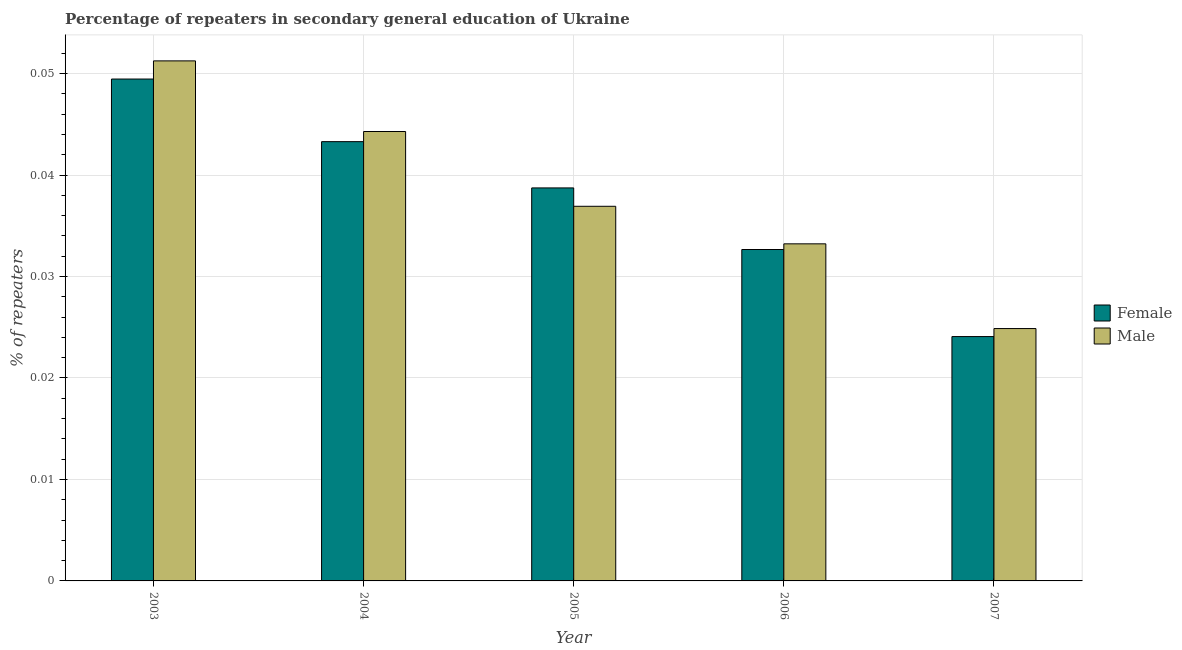How many bars are there on the 5th tick from the left?
Offer a terse response. 2. What is the percentage of female repeaters in 2003?
Keep it short and to the point. 0.05. Across all years, what is the maximum percentage of female repeaters?
Offer a very short reply. 0.05. Across all years, what is the minimum percentage of female repeaters?
Your answer should be compact. 0.02. In which year was the percentage of female repeaters minimum?
Make the answer very short. 2007. What is the total percentage of female repeaters in the graph?
Give a very brief answer. 0.19. What is the difference between the percentage of female repeaters in 2004 and that in 2006?
Keep it short and to the point. 0.01. What is the difference between the percentage of male repeaters in 2005 and the percentage of female repeaters in 2006?
Offer a terse response. 0. What is the average percentage of male repeaters per year?
Provide a succinct answer. 0.04. In the year 2003, what is the difference between the percentage of female repeaters and percentage of male repeaters?
Provide a succinct answer. 0. In how many years, is the percentage of male repeaters greater than 0.04 %?
Make the answer very short. 2. What is the ratio of the percentage of female repeaters in 2005 to that in 2007?
Keep it short and to the point. 1.61. What is the difference between the highest and the second highest percentage of female repeaters?
Provide a short and direct response. 0.01. What is the difference between the highest and the lowest percentage of male repeaters?
Provide a short and direct response. 0.03. Is the sum of the percentage of female repeaters in 2004 and 2007 greater than the maximum percentage of male repeaters across all years?
Your response must be concise. Yes. What does the 2nd bar from the left in 2004 represents?
Ensure brevity in your answer.  Male. How many bars are there?
Your response must be concise. 10. How many years are there in the graph?
Offer a very short reply. 5. Are the values on the major ticks of Y-axis written in scientific E-notation?
Ensure brevity in your answer.  No. Does the graph contain grids?
Provide a succinct answer. Yes. How are the legend labels stacked?
Offer a terse response. Vertical. What is the title of the graph?
Offer a very short reply. Percentage of repeaters in secondary general education of Ukraine. What is the label or title of the Y-axis?
Make the answer very short. % of repeaters. What is the % of repeaters in Female in 2003?
Your answer should be compact. 0.05. What is the % of repeaters of Male in 2003?
Provide a succinct answer. 0.05. What is the % of repeaters in Female in 2004?
Offer a terse response. 0.04. What is the % of repeaters in Male in 2004?
Keep it short and to the point. 0.04. What is the % of repeaters of Female in 2005?
Make the answer very short. 0.04. What is the % of repeaters of Male in 2005?
Your answer should be very brief. 0.04. What is the % of repeaters of Female in 2006?
Provide a short and direct response. 0.03. What is the % of repeaters in Male in 2006?
Your response must be concise. 0.03. What is the % of repeaters of Female in 2007?
Make the answer very short. 0.02. What is the % of repeaters in Male in 2007?
Make the answer very short. 0.02. Across all years, what is the maximum % of repeaters of Female?
Your answer should be compact. 0.05. Across all years, what is the maximum % of repeaters in Male?
Provide a succinct answer. 0.05. Across all years, what is the minimum % of repeaters in Female?
Make the answer very short. 0.02. Across all years, what is the minimum % of repeaters of Male?
Give a very brief answer. 0.02. What is the total % of repeaters of Female in the graph?
Offer a terse response. 0.19. What is the total % of repeaters of Male in the graph?
Your answer should be very brief. 0.19. What is the difference between the % of repeaters in Female in 2003 and that in 2004?
Ensure brevity in your answer.  0.01. What is the difference between the % of repeaters in Male in 2003 and that in 2004?
Your response must be concise. 0.01. What is the difference between the % of repeaters in Female in 2003 and that in 2005?
Give a very brief answer. 0.01. What is the difference between the % of repeaters of Male in 2003 and that in 2005?
Give a very brief answer. 0.01. What is the difference between the % of repeaters in Female in 2003 and that in 2006?
Give a very brief answer. 0.02. What is the difference between the % of repeaters in Male in 2003 and that in 2006?
Give a very brief answer. 0.02. What is the difference between the % of repeaters of Female in 2003 and that in 2007?
Your answer should be compact. 0.03. What is the difference between the % of repeaters in Male in 2003 and that in 2007?
Make the answer very short. 0.03. What is the difference between the % of repeaters in Female in 2004 and that in 2005?
Offer a terse response. 0. What is the difference between the % of repeaters in Male in 2004 and that in 2005?
Keep it short and to the point. 0.01. What is the difference between the % of repeaters in Female in 2004 and that in 2006?
Keep it short and to the point. 0.01. What is the difference between the % of repeaters of Male in 2004 and that in 2006?
Make the answer very short. 0.01. What is the difference between the % of repeaters in Female in 2004 and that in 2007?
Ensure brevity in your answer.  0.02. What is the difference between the % of repeaters of Male in 2004 and that in 2007?
Provide a succinct answer. 0.02. What is the difference between the % of repeaters of Female in 2005 and that in 2006?
Offer a terse response. 0.01. What is the difference between the % of repeaters of Male in 2005 and that in 2006?
Ensure brevity in your answer.  0. What is the difference between the % of repeaters of Female in 2005 and that in 2007?
Make the answer very short. 0.01. What is the difference between the % of repeaters in Male in 2005 and that in 2007?
Make the answer very short. 0.01. What is the difference between the % of repeaters in Female in 2006 and that in 2007?
Your response must be concise. 0.01. What is the difference between the % of repeaters in Male in 2006 and that in 2007?
Offer a very short reply. 0.01. What is the difference between the % of repeaters in Female in 2003 and the % of repeaters in Male in 2004?
Offer a terse response. 0.01. What is the difference between the % of repeaters in Female in 2003 and the % of repeaters in Male in 2005?
Your response must be concise. 0.01. What is the difference between the % of repeaters in Female in 2003 and the % of repeaters in Male in 2006?
Provide a succinct answer. 0.02. What is the difference between the % of repeaters of Female in 2003 and the % of repeaters of Male in 2007?
Offer a very short reply. 0.02. What is the difference between the % of repeaters in Female in 2004 and the % of repeaters in Male in 2005?
Ensure brevity in your answer.  0.01. What is the difference between the % of repeaters of Female in 2004 and the % of repeaters of Male in 2006?
Your response must be concise. 0.01. What is the difference between the % of repeaters of Female in 2004 and the % of repeaters of Male in 2007?
Provide a succinct answer. 0.02. What is the difference between the % of repeaters in Female in 2005 and the % of repeaters in Male in 2006?
Your response must be concise. 0.01. What is the difference between the % of repeaters of Female in 2005 and the % of repeaters of Male in 2007?
Make the answer very short. 0.01. What is the difference between the % of repeaters of Female in 2006 and the % of repeaters of Male in 2007?
Keep it short and to the point. 0.01. What is the average % of repeaters of Female per year?
Give a very brief answer. 0.04. What is the average % of repeaters of Male per year?
Keep it short and to the point. 0.04. In the year 2003, what is the difference between the % of repeaters of Female and % of repeaters of Male?
Your answer should be very brief. -0. In the year 2004, what is the difference between the % of repeaters of Female and % of repeaters of Male?
Give a very brief answer. -0. In the year 2005, what is the difference between the % of repeaters of Female and % of repeaters of Male?
Offer a terse response. 0. In the year 2006, what is the difference between the % of repeaters of Female and % of repeaters of Male?
Provide a short and direct response. -0. In the year 2007, what is the difference between the % of repeaters of Female and % of repeaters of Male?
Your answer should be compact. -0. What is the ratio of the % of repeaters of Female in 2003 to that in 2004?
Offer a very short reply. 1.14. What is the ratio of the % of repeaters of Male in 2003 to that in 2004?
Your answer should be very brief. 1.16. What is the ratio of the % of repeaters of Female in 2003 to that in 2005?
Your answer should be compact. 1.28. What is the ratio of the % of repeaters in Male in 2003 to that in 2005?
Your answer should be compact. 1.39. What is the ratio of the % of repeaters in Female in 2003 to that in 2006?
Provide a short and direct response. 1.51. What is the ratio of the % of repeaters of Male in 2003 to that in 2006?
Give a very brief answer. 1.54. What is the ratio of the % of repeaters in Female in 2003 to that in 2007?
Ensure brevity in your answer.  2.05. What is the ratio of the % of repeaters of Male in 2003 to that in 2007?
Your response must be concise. 2.06. What is the ratio of the % of repeaters in Female in 2004 to that in 2005?
Offer a terse response. 1.12. What is the ratio of the % of repeaters in Male in 2004 to that in 2005?
Your answer should be very brief. 1.2. What is the ratio of the % of repeaters in Female in 2004 to that in 2006?
Your answer should be very brief. 1.33. What is the ratio of the % of repeaters of Male in 2004 to that in 2006?
Provide a short and direct response. 1.33. What is the ratio of the % of repeaters of Female in 2004 to that in 2007?
Your answer should be very brief. 1.8. What is the ratio of the % of repeaters of Male in 2004 to that in 2007?
Your answer should be compact. 1.78. What is the ratio of the % of repeaters of Female in 2005 to that in 2006?
Provide a succinct answer. 1.19. What is the ratio of the % of repeaters of Male in 2005 to that in 2006?
Keep it short and to the point. 1.11. What is the ratio of the % of repeaters of Female in 2005 to that in 2007?
Keep it short and to the point. 1.61. What is the ratio of the % of repeaters in Male in 2005 to that in 2007?
Offer a terse response. 1.48. What is the ratio of the % of repeaters in Female in 2006 to that in 2007?
Keep it short and to the point. 1.36. What is the ratio of the % of repeaters of Male in 2006 to that in 2007?
Offer a very short reply. 1.34. What is the difference between the highest and the second highest % of repeaters of Female?
Your answer should be compact. 0.01. What is the difference between the highest and the second highest % of repeaters of Male?
Your answer should be very brief. 0.01. What is the difference between the highest and the lowest % of repeaters of Female?
Offer a very short reply. 0.03. What is the difference between the highest and the lowest % of repeaters of Male?
Ensure brevity in your answer.  0.03. 